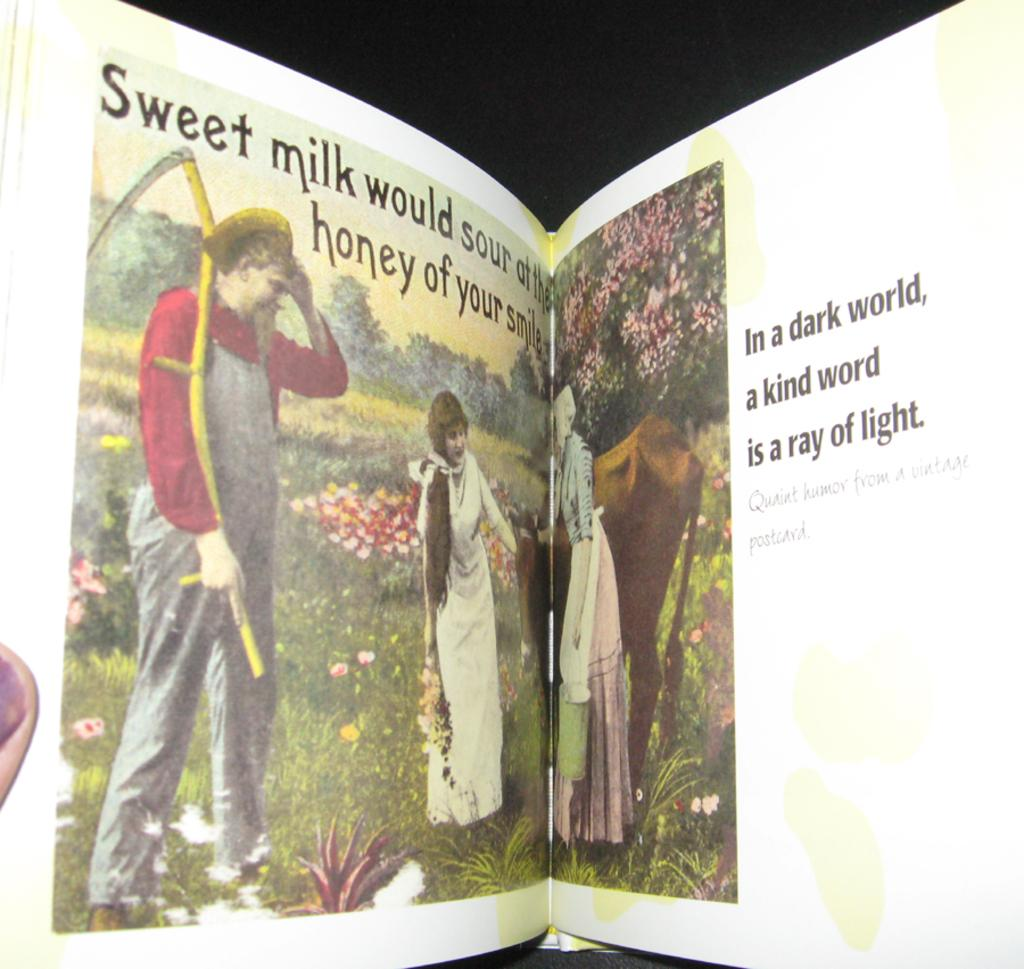<image>
Relay a brief, clear account of the picture shown. An opened book with the words sweet milk on the left page. 